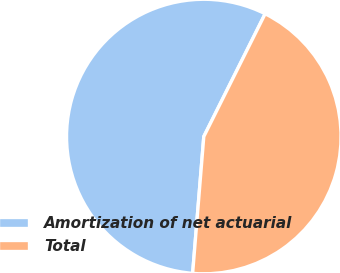Convert chart to OTSL. <chart><loc_0><loc_0><loc_500><loc_500><pie_chart><fcel>Amortization of net actuarial<fcel>Total<nl><fcel>56.08%<fcel>43.92%<nl></chart> 